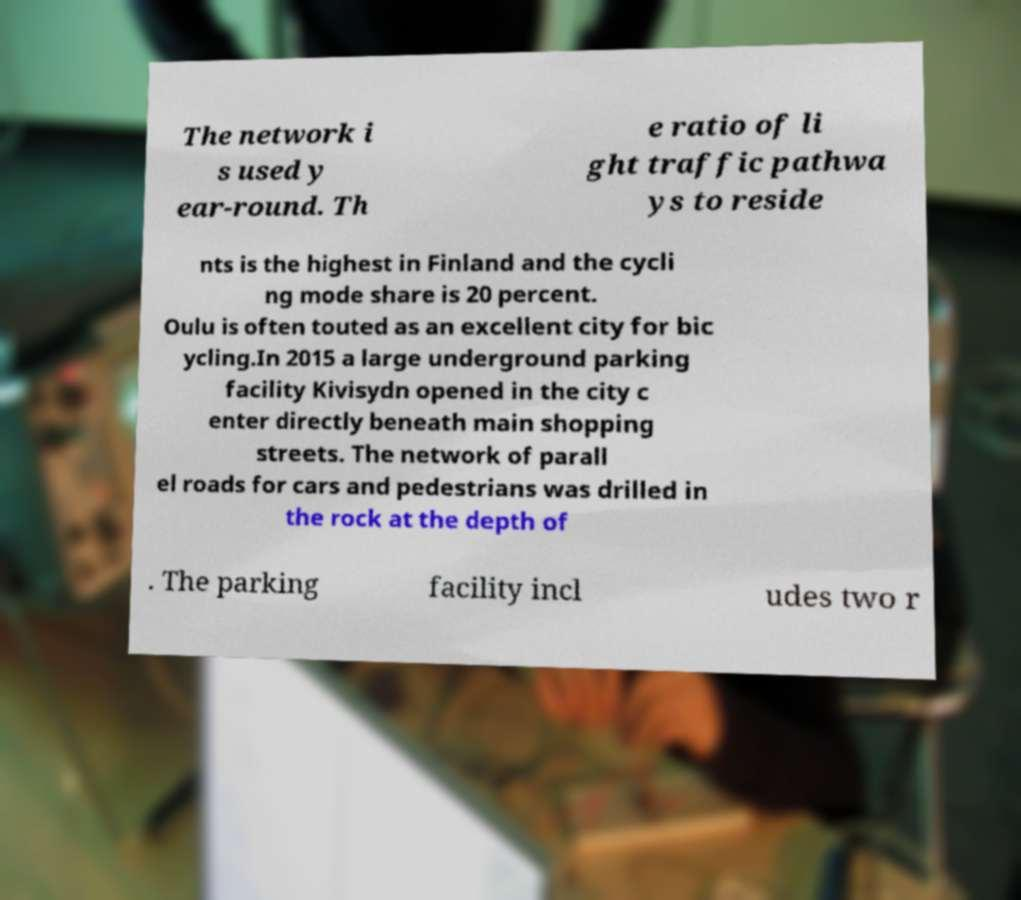For documentation purposes, I need the text within this image transcribed. Could you provide that? The network i s used y ear-round. Th e ratio of li ght traffic pathwa ys to reside nts is the highest in Finland and the cycli ng mode share is 20 percent. Oulu is often touted as an excellent city for bic ycling.In 2015 a large underground parking facility Kivisydn opened in the city c enter directly beneath main shopping streets. The network of parall el roads for cars and pedestrians was drilled in the rock at the depth of . The parking facility incl udes two r 